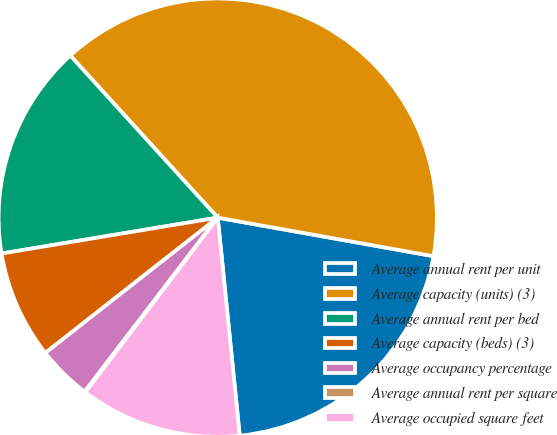<chart> <loc_0><loc_0><loc_500><loc_500><pie_chart><fcel>Average annual rent per unit<fcel>Average capacity (units) (3)<fcel>Average annual rent per bed<fcel>Average capacity (beds) (3)<fcel>Average occupancy percentage<fcel>Average annual rent per square<fcel>Average occupied square feet<nl><fcel>20.59%<fcel>39.56%<fcel>15.87%<fcel>7.97%<fcel>4.02%<fcel>0.07%<fcel>11.92%<nl></chart> 